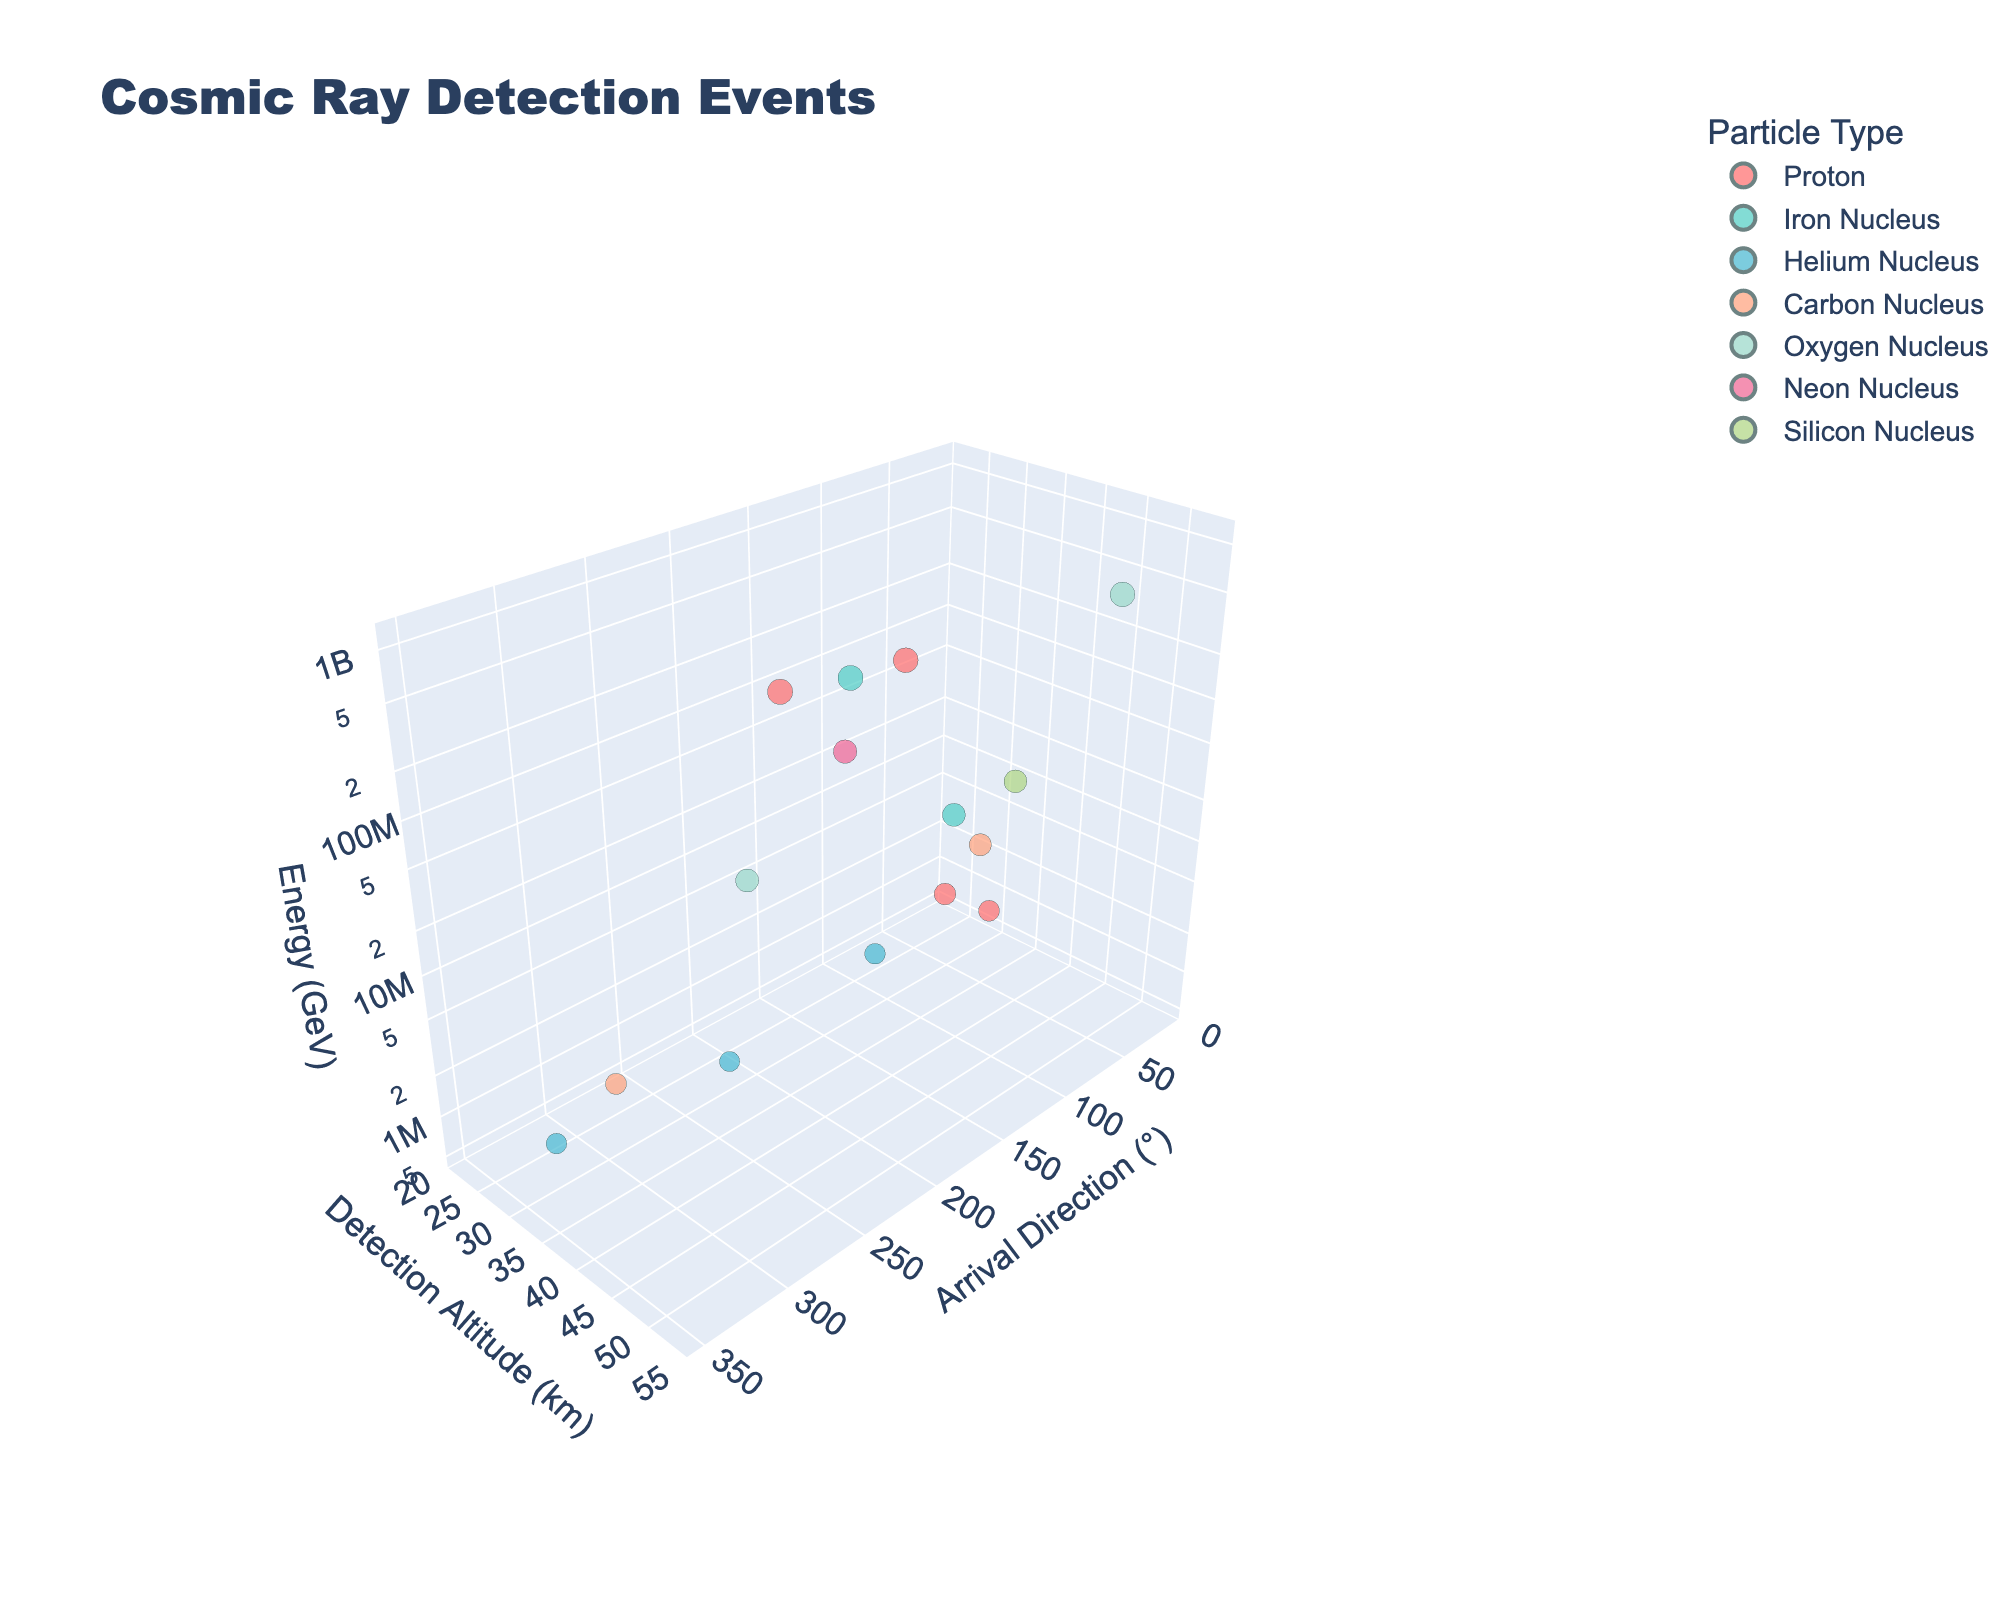What is the title of the chart? The title of the chart is located at the top and displays the overall subject of the visualization, which helps provide context for understanding the data.
Answer: Cosmic Ray Detection Events How many particle types are represented in the chart? By examining the legend on the right side of the chart, each unique entry corresponds to a particle type. Count all distinct particle types mentioned.
Answer: Seven Which data point has the highest energy, and what is its detection altitude? Identify the largest bubble as larger bubbles represent higher energy. Then, hover over the bubble or use the data labels to find the detection altitude.
Answer: 1.1e9 GeV, 50 km What is the average detection altitude for Helium Nucleus events? Identify all Helium Nucleus data points by their color. Note their altitudes, sum them up, and then divide by the number of data points. (Altitudes: 28, 30, 29; Sum: 87; Average: 87/3)
Answer: 29 km Which particle type has the widest range of arrival directions? Observe the x-axis positions of the bubbles for each particle type. The type that spans the largest interval in degrees has the widest range.
Answer: Helium Nucleus Is there any particle type with more than one detection altitude recorded? If yes, which one(s)? By finding each particle type, note if more than one y-axis value appears for any of them. Multiple distinct y-values imply more than one detection altitude.
Answer: Proton List the particle types that have data points detected at an altitude of 45 km. Identify all bubbles situated at the y-axis value of 45 km and check their colors or hover labels to list the corresponding particle types.
Answer: Oxygen Nucleus How do the arrival directions of Protons compare to Iron Nuclei? Compare the x-axis ranges for Protons and Iron Nuclei. Note which type spans a broader interval or if either type's arrival directions are more concentrated.
Answer: Protons have a wider range Regarding detection altitudes, which particle type tends to be detected at higher altitudes? For each particle type, observe the y-axis positioning of their bubbles and identify which type has most of its bubbles at higher y-values.
Answer: Proton What is the ratio of the highest energy data point's altitude to the lowest energy data point's altitude? Identify the altitudes of the highest (1.1e9 GeV at 50 km) and lowest (5.2e5 GeV at 28 km) energy data points. Calculate the ratio (50/28).
Answer: 1.79 